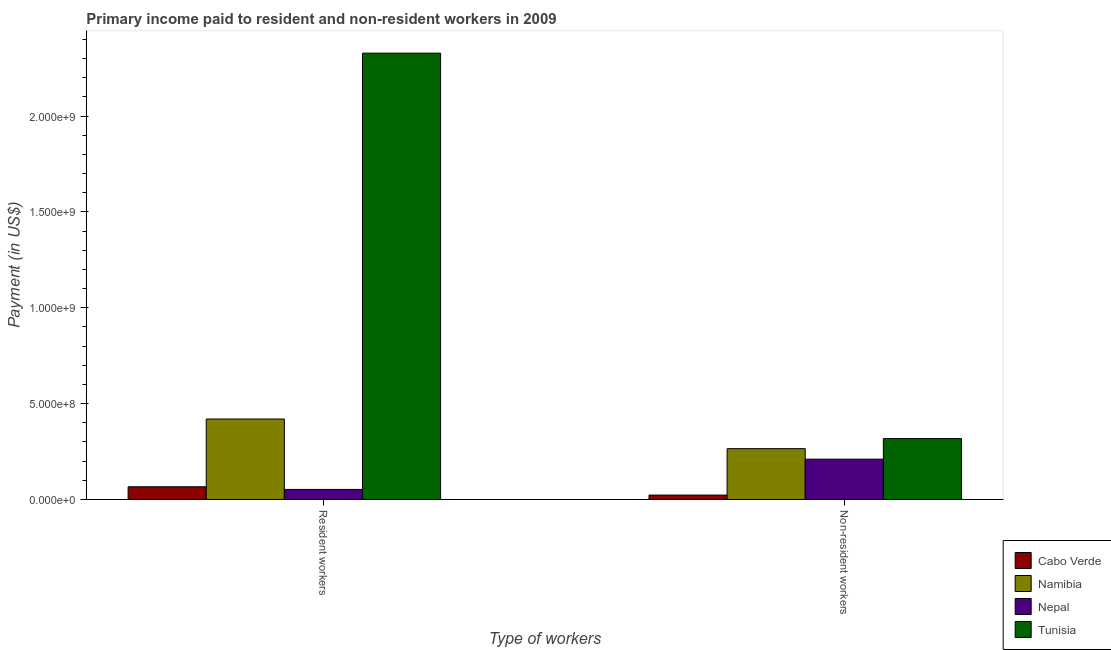Are the number of bars per tick equal to the number of legend labels?
Your answer should be compact. Yes. Are the number of bars on each tick of the X-axis equal?
Your answer should be compact. Yes. How many bars are there on the 2nd tick from the left?
Keep it short and to the point. 4. How many bars are there on the 2nd tick from the right?
Make the answer very short. 4. What is the label of the 2nd group of bars from the left?
Give a very brief answer. Non-resident workers. What is the payment made to resident workers in Namibia?
Your response must be concise. 4.20e+08. Across all countries, what is the maximum payment made to non-resident workers?
Give a very brief answer. 3.18e+08. Across all countries, what is the minimum payment made to non-resident workers?
Provide a short and direct response. 2.29e+07. In which country was the payment made to resident workers maximum?
Give a very brief answer. Tunisia. In which country was the payment made to non-resident workers minimum?
Your response must be concise. Cabo Verde. What is the total payment made to resident workers in the graph?
Keep it short and to the point. 2.87e+09. What is the difference between the payment made to non-resident workers in Cabo Verde and that in Namibia?
Your answer should be very brief. -2.42e+08. What is the difference between the payment made to non-resident workers in Nepal and the payment made to resident workers in Tunisia?
Ensure brevity in your answer.  -2.12e+09. What is the average payment made to non-resident workers per country?
Give a very brief answer. 2.04e+08. What is the difference between the payment made to resident workers and payment made to non-resident workers in Nepal?
Your answer should be compact. -1.58e+08. What is the ratio of the payment made to resident workers in Tunisia to that in Namibia?
Offer a terse response. 5.55. Is the payment made to resident workers in Cabo Verde less than that in Nepal?
Your answer should be compact. No. In how many countries, is the payment made to resident workers greater than the average payment made to resident workers taken over all countries?
Your response must be concise. 1. What does the 4th bar from the left in Resident workers represents?
Provide a succinct answer. Tunisia. What does the 4th bar from the right in Resident workers represents?
Ensure brevity in your answer.  Cabo Verde. What is the difference between two consecutive major ticks on the Y-axis?
Make the answer very short. 5.00e+08. Are the values on the major ticks of Y-axis written in scientific E-notation?
Provide a succinct answer. Yes. Does the graph contain any zero values?
Offer a terse response. No. How many legend labels are there?
Ensure brevity in your answer.  4. How are the legend labels stacked?
Your response must be concise. Vertical. What is the title of the graph?
Keep it short and to the point. Primary income paid to resident and non-resident workers in 2009. What is the label or title of the X-axis?
Ensure brevity in your answer.  Type of workers. What is the label or title of the Y-axis?
Offer a terse response. Payment (in US$). What is the Payment (in US$) in Cabo Verde in Resident workers?
Give a very brief answer. 6.63e+07. What is the Payment (in US$) in Namibia in Resident workers?
Your answer should be very brief. 4.20e+08. What is the Payment (in US$) of Nepal in Resident workers?
Your response must be concise. 5.23e+07. What is the Payment (in US$) in Tunisia in Resident workers?
Give a very brief answer. 2.33e+09. What is the Payment (in US$) in Cabo Verde in Non-resident workers?
Your answer should be very brief. 2.29e+07. What is the Payment (in US$) in Namibia in Non-resident workers?
Your response must be concise. 2.65e+08. What is the Payment (in US$) of Nepal in Non-resident workers?
Your answer should be compact. 2.10e+08. What is the Payment (in US$) of Tunisia in Non-resident workers?
Your answer should be compact. 3.18e+08. Across all Type of workers, what is the maximum Payment (in US$) of Cabo Verde?
Offer a terse response. 6.63e+07. Across all Type of workers, what is the maximum Payment (in US$) of Namibia?
Make the answer very short. 4.20e+08. Across all Type of workers, what is the maximum Payment (in US$) in Nepal?
Make the answer very short. 2.10e+08. Across all Type of workers, what is the maximum Payment (in US$) in Tunisia?
Keep it short and to the point. 2.33e+09. Across all Type of workers, what is the minimum Payment (in US$) in Cabo Verde?
Make the answer very short. 2.29e+07. Across all Type of workers, what is the minimum Payment (in US$) in Namibia?
Provide a succinct answer. 2.65e+08. Across all Type of workers, what is the minimum Payment (in US$) of Nepal?
Offer a very short reply. 5.23e+07. Across all Type of workers, what is the minimum Payment (in US$) in Tunisia?
Make the answer very short. 3.18e+08. What is the total Payment (in US$) of Cabo Verde in the graph?
Provide a short and direct response. 8.92e+07. What is the total Payment (in US$) of Namibia in the graph?
Make the answer very short. 6.85e+08. What is the total Payment (in US$) in Nepal in the graph?
Offer a very short reply. 2.62e+08. What is the total Payment (in US$) of Tunisia in the graph?
Keep it short and to the point. 2.65e+09. What is the difference between the Payment (in US$) of Cabo Verde in Resident workers and that in Non-resident workers?
Provide a short and direct response. 4.34e+07. What is the difference between the Payment (in US$) of Namibia in Resident workers and that in Non-resident workers?
Keep it short and to the point. 1.55e+08. What is the difference between the Payment (in US$) in Nepal in Resident workers and that in Non-resident workers?
Offer a very short reply. -1.58e+08. What is the difference between the Payment (in US$) of Tunisia in Resident workers and that in Non-resident workers?
Keep it short and to the point. 2.01e+09. What is the difference between the Payment (in US$) in Cabo Verde in Resident workers and the Payment (in US$) in Namibia in Non-resident workers?
Offer a terse response. -1.99e+08. What is the difference between the Payment (in US$) of Cabo Verde in Resident workers and the Payment (in US$) of Nepal in Non-resident workers?
Keep it short and to the point. -1.44e+08. What is the difference between the Payment (in US$) of Cabo Verde in Resident workers and the Payment (in US$) of Tunisia in Non-resident workers?
Provide a succinct answer. -2.51e+08. What is the difference between the Payment (in US$) in Namibia in Resident workers and the Payment (in US$) in Nepal in Non-resident workers?
Your answer should be compact. 2.10e+08. What is the difference between the Payment (in US$) of Namibia in Resident workers and the Payment (in US$) of Tunisia in Non-resident workers?
Offer a very short reply. 1.02e+08. What is the difference between the Payment (in US$) of Nepal in Resident workers and the Payment (in US$) of Tunisia in Non-resident workers?
Offer a terse response. -2.65e+08. What is the average Payment (in US$) in Cabo Verde per Type of workers?
Offer a very short reply. 4.46e+07. What is the average Payment (in US$) of Namibia per Type of workers?
Offer a very short reply. 3.42e+08. What is the average Payment (in US$) in Nepal per Type of workers?
Keep it short and to the point. 1.31e+08. What is the average Payment (in US$) in Tunisia per Type of workers?
Provide a short and direct response. 1.32e+09. What is the difference between the Payment (in US$) in Cabo Verde and Payment (in US$) in Namibia in Resident workers?
Ensure brevity in your answer.  -3.53e+08. What is the difference between the Payment (in US$) of Cabo Verde and Payment (in US$) of Nepal in Resident workers?
Your answer should be very brief. 1.40e+07. What is the difference between the Payment (in US$) of Cabo Verde and Payment (in US$) of Tunisia in Resident workers?
Offer a very short reply. -2.26e+09. What is the difference between the Payment (in US$) in Namibia and Payment (in US$) in Nepal in Resident workers?
Offer a terse response. 3.67e+08. What is the difference between the Payment (in US$) in Namibia and Payment (in US$) in Tunisia in Resident workers?
Provide a succinct answer. -1.91e+09. What is the difference between the Payment (in US$) of Nepal and Payment (in US$) of Tunisia in Resident workers?
Make the answer very short. -2.28e+09. What is the difference between the Payment (in US$) of Cabo Verde and Payment (in US$) of Namibia in Non-resident workers?
Give a very brief answer. -2.42e+08. What is the difference between the Payment (in US$) in Cabo Verde and Payment (in US$) in Nepal in Non-resident workers?
Your response must be concise. -1.87e+08. What is the difference between the Payment (in US$) of Cabo Verde and Payment (in US$) of Tunisia in Non-resident workers?
Provide a short and direct response. -2.95e+08. What is the difference between the Payment (in US$) in Namibia and Payment (in US$) in Nepal in Non-resident workers?
Your answer should be compact. 5.48e+07. What is the difference between the Payment (in US$) of Namibia and Payment (in US$) of Tunisia in Non-resident workers?
Offer a terse response. -5.26e+07. What is the difference between the Payment (in US$) of Nepal and Payment (in US$) of Tunisia in Non-resident workers?
Provide a short and direct response. -1.07e+08. What is the ratio of the Payment (in US$) of Cabo Verde in Resident workers to that in Non-resident workers?
Ensure brevity in your answer.  2.9. What is the ratio of the Payment (in US$) in Namibia in Resident workers to that in Non-resident workers?
Your response must be concise. 1.58. What is the ratio of the Payment (in US$) of Nepal in Resident workers to that in Non-resident workers?
Keep it short and to the point. 0.25. What is the ratio of the Payment (in US$) of Tunisia in Resident workers to that in Non-resident workers?
Keep it short and to the point. 7.33. What is the difference between the highest and the second highest Payment (in US$) of Cabo Verde?
Your response must be concise. 4.34e+07. What is the difference between the highest and the second highest Payment (in US$) of Namibia?
Your answer should be very brief. 1.55e+08. What is the difference between the highest and the second highest Payment (in US$) in Nepal?
Offer a very short reply. 1.58e+08. What is the difference between the highest and the second highest Payment (in US$) in Tunisia?
Offer a terse response. 2.01e+09. What is the difference between the highest and the lowest Payment (in US$) of Cabo Verde?
Provide a succinct answer. 4.34e+07. What is the difference between the highest and the lowest Payment (in US$) of Namibia?
Give a very brief answer. 1.55e+08. What is the difference between the highest and the lowest Payment (in US$) of Nepal?
Your response must be concise. 1.58e+08. What is the difference between the highest and the lowest Payment (in US$) in Tunisia?
Give a very brief answer. 2.01e+09. 